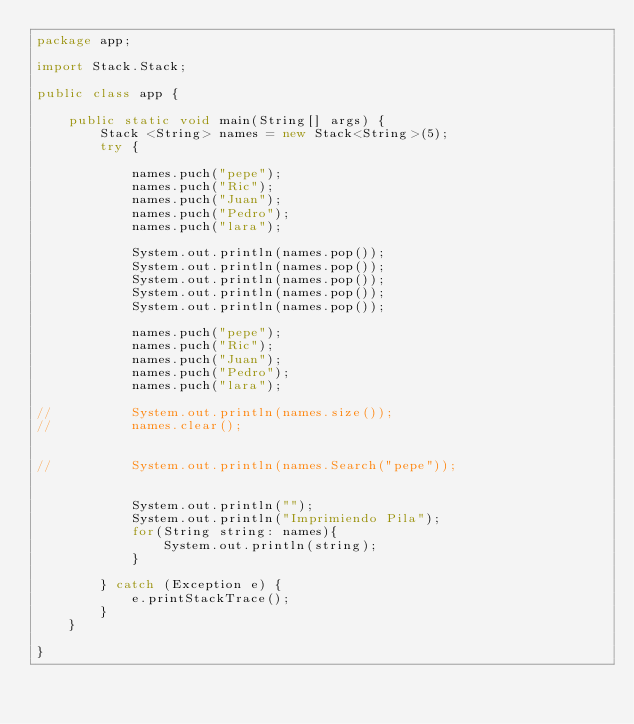<code> <loc_0><loc_0><loc_500><loc_500><_Java_>package app;

import Stack.Stack;

public class app {

	public static void main(String[] args) {
		Stack <String> names = new Stack<String>(5);
		try {
			
			names.puch("pepe");
			names.puch("Ric");
			names.puch("Juan");
			names.puch("Pedro");
			names.puch("lara");
			
			System.out.println(names.pop());
			System.out.println(names.pop());
			System.out.println(names.pop());
			System.out.println(names.pop());
     		System.out.println(names.pop());
			
			names.puch("pepe");
			names.puch("Ric");
			names.puch("Juan");
			names.puch("Pedro");
			names.puch("lara");
			
//			System.out.println(names.size());
//			names.clear();
			
			
//			System.out.println(names.Search("pepe"));
			
			
			System.out.println("");
			System.out.println("Imprimiendo Pila");
			for(String string: names){
				System.out.println(string);
			}
			
		} catch (Exception e) {
			e.printStackTrace();
		}
	}

}
</code> 